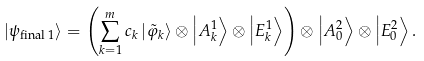Convert formula to latex. <formula><loc_0><loc_0><loc_500><loc_500>\left | \psi _ { \text {final 1} } \right \rangle = \left ( \sum _ { k = 1 } ^ { m } c _ { k } \left | \tilde { \varphi } _ { k } \right \rangle \otimes \left | A _ { k } ^ { 1 } \right \rangle \otimes \left | E _ { k } ^ { 1 } \right \rangle \right ) \otimes \left | A _ { 0 } ^ { 2 } \right \rangle \otimes \left | E _ { 0 } ^ { 2 } \right \rangle .</formula> 